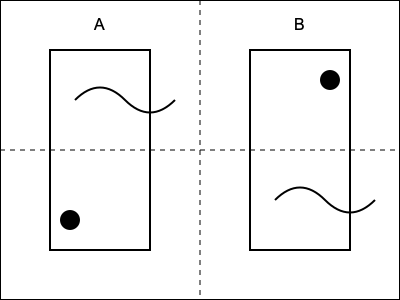If you fold this sheet of music along the dotted lines, which musical notation symbols will overlap? To solve this puzzle, we need to follow these steps:

1. Observe that the sheet is divided into four quadrants by the dotted lines.
2. Quadrants A and B contain different musical notation symbols.
3. In quadrant A, we see a curved line (likely representing a slur or tie) and a filled circle (likely representing a whole note).
4. In quadrant B, we see a similar curved line and a filled circle, but in different positions.
5. If we fold the sheet along the vertical dotted line, the left half will overlap the right half.
6. When this happens, quadrant A will overlap with quadrant B.
7. The curved line in quadrant A is at the top, while the curved line in quadrant B is at the bottom. These will not overlap.
8. However, the filled circle (whole note) in quadrant A is at the bottom, and the filled circle in quadrant B is at the top.
9. When folded, these two filled circles will align and overlap.

Therefore, the musical notation symbols that will overlap when the sheet is folded are the filled circles, which likely represent whole notes.
Answer: Whole notes 